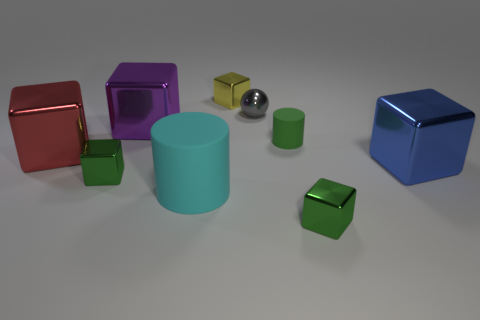Subtract 2 cubes. How many cubes are left? 4 Subtract all blue cubes. How many cubes are left? 5 Subtract all green blocks. How many blocks are left? 4 Subtract all red cubes. Subtract all yellow cylinders. How many cubes are left? 5 Subtract all cubes. How many objects are left? 3 Subtract all big blue matte things. Subtract all large matte objects. How many objects are left? 8 Add 1 cyan matte cylinders. How many cyan matte cylinders are left? 2 Add 5 small brown cubes. How many small brown cubes exist? 5 Subtract 0 purple cylinders. How many objects are left? 9 